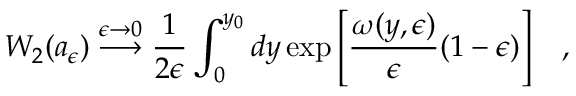Convert formula to latex. <formula><loc_0><loc_0><loc_500><loc_500>W _ { 2 } ( a _ { \epsilon } ) \stackrel { \epsilon \rightarrow 0 } { \longrightarrow } { \frac { 1 } { 2 \epsilon } } \int _ { 0 } ^ { y _ { 0 } } d y \exp \left [ { \frac { \omega ( y , \epsilon ) } { \epsilon } } ( 1 - \epsilon ) \right ] \, ,</formula> 